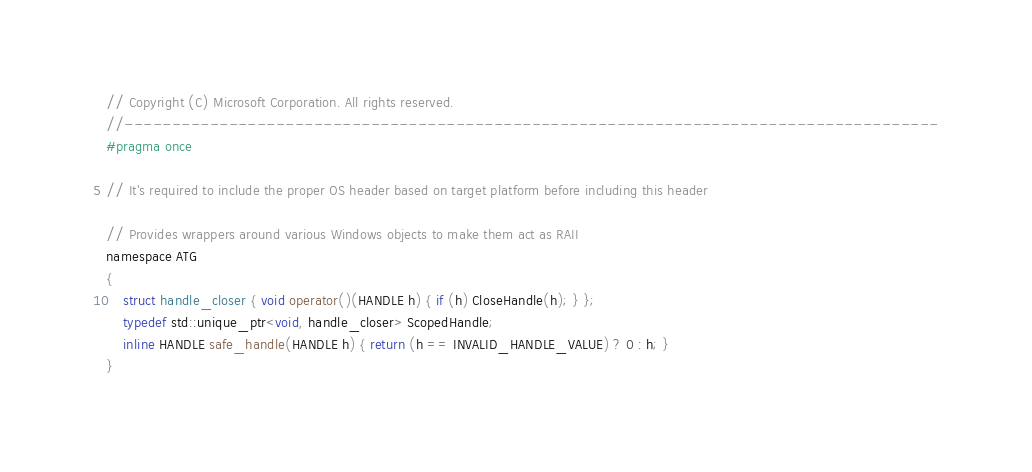Convert code to text. <code><loc_0><loc_0><loc_500><loc_500><_C_>// Copyright (C) Microsoft Corporation. All rights reserved.
//--------------------------------------------------------------------------------------
#pragma once

// It's required to include the proper OS header based on target platform before including this header

// Provides wrappers around various Windows objects to make them act as RAII
namespace ATG
{
    struct handle_closer { void operator()(HANDLE h) { if (h) CloseHandle(h); } };
    typedef std::unique_ptr<void, handle_closer> ScopedHandle;
    inline HANDLE safe_handle(HANDLE h) { return (h == INVALID_HANDLE_VALUE) ? 0 : h; }
}
</code> 